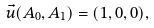Convert formula to latex. <formula><loc_0><loc_0><loc_500><loc_500>\vec { u } ( A _ { 0 } , A _ { 1 } ) = ( 1 , 0 , 0 ) ,</formula> 